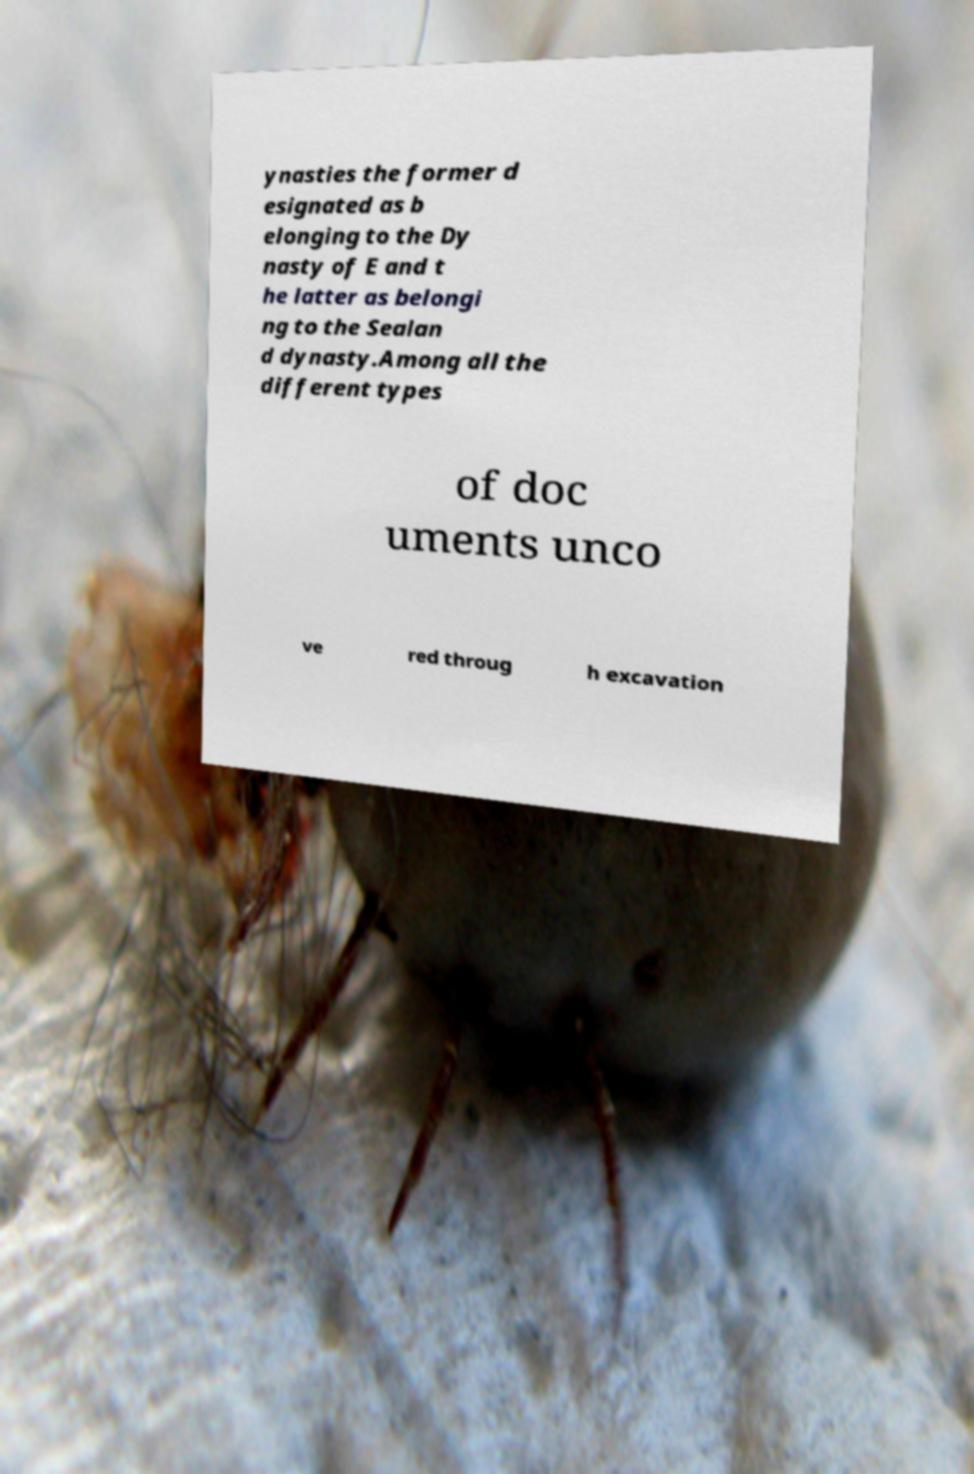What messages or text are displayed in this image? I need them in a readable, typed format. ynasties the former d esignated as b elonging to the Dy nasty of E and t he latter as belongi ng to the Sealan d dynasty.Among all the different types of doc uments unco ve red throug h excavation 